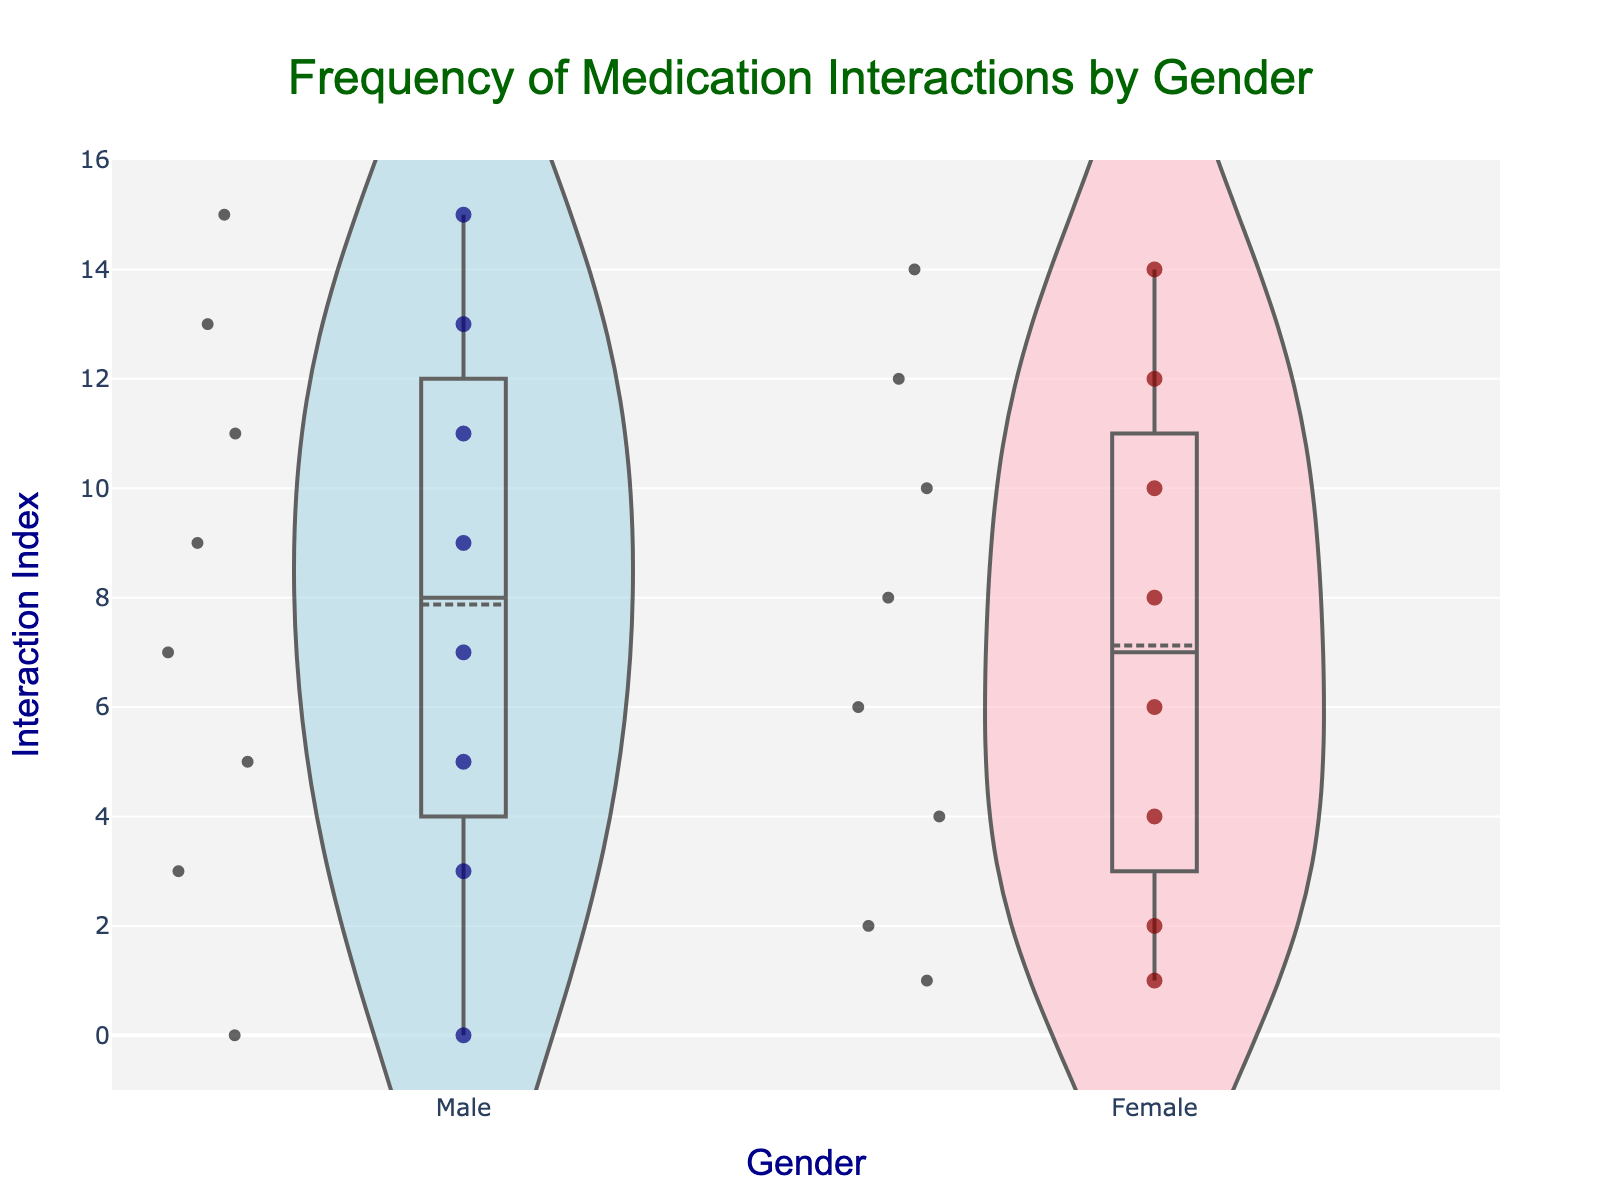What's the title of the chart? The title of the chart is prominently displayed at the top. It reads, "Frequency of Medication Interactions by Gender".
Answer: Frequency of Medication Interactions by Gender What colors represent males and females in the plot? The plot uses different colors for males and females. Males are represented by light blue color, and females are represented by pink color.
Answer: Light blue for males, pink for females How many medication interactions were reported by males? The violin plot includes several points on the male side, each representing a reported interaction. By counting the points, we see that 8 interactions were reported by males.
Answer: 8 Which gender reported the most frequent interaction types? To determine which gender reported more types, we compare the density and number of points in each violin plot. Females have more data points, indicating they reported more interaction types.
Answer: Females Which gender has a higher median interaction index? The median interaction index can be inferred from the meanline within each violin plot. By examining these lines, it's visible that the median for females is slightly higher than that for males.
Answer: Females How many points are there for each gender? Observing each side of the violin plot, count the number of jittered points. There are 8 points each for both males and females.
Answer: 8 What's the interaction reported most frequently for males? By hovering over or examining each interaction point on the male side, we find that 'Dizziness' appears twice for males, making it the most frequent type.
Answer: Dizziness Which gender shows more variability in interaction types? Variability can be inferred from the width and spread of the violin plots. Females have a wider spread and show more variability in interaction types.
Answer: Females Does the chart indicate which gender experiences more severe side effects? To deduce the severity, we look at the types and range of interactions reported. If assuming severe side effects encompass a wider range, females appear to experience more severe side effects due to a varied range of interactions reported.
Answer: Females What's the distribution pattern of interaction indexes for females? By examining the density of the violin plot and the spread of the jittered points for females, we see that interactions are more concentrated towards certain index values, indicating a non-uniform distribution.
Answer: Non-uniform distribution 